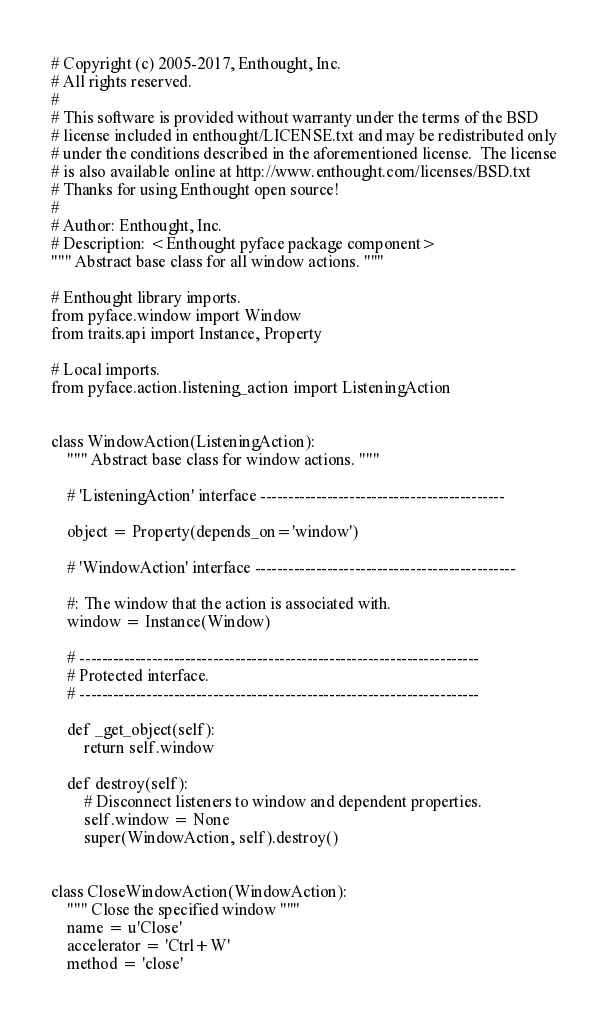<code> <loc_0><loc_0><loc_500><loc_500><_Python_># Copyright (c) 2005-2017, Enthought, Inc.
# All rights reserved.
#
# This software is provided without warranty under the terms of the BSD
# license included in enthought/LICENSE.txt and may be redistributed only
# under the conditions described in the aforementioned license.  The license
# is also available online at http://www.enthought.com/licenses/BSD.txt
# Thanks for using Enthought open source!
#
# Author: Enthought, Inc.
# Description: <Enthought pyface package component>
""" Abstract base class for all window actions. """

# Enthought library imports.
from pyface.window import Window
from traits.api import Instance, Property

# Local imports.
from pyface.action.listening_action import ListeningAction


class WindowAction(ListeningAction):
    """ Abstract base class for window actions. """

    # 'ListeningAction' interface --------------------------------------------

    object = Property(depends_on='window')

    # 'WindowAction' interface -----------------------------------------------

    #: The window that the action is associated with.
    window = Instance(Window)

    # ------------------------------------------------------------------------
    # Protected interface.
    # ------------------------------------------------------------------------

    def _get_object(self):
        return self.window

    def destroy(self):
        # Disconnect listeners to window and dependent properties.
        self.window = None
        super(WindowAction, self).destroy()


class CloseWindowAction(WindowAction):
    """ Close the specified window """
    name = u'Close'
    accelerator = 'Ctrl+W'
    method = 'close'</code> 